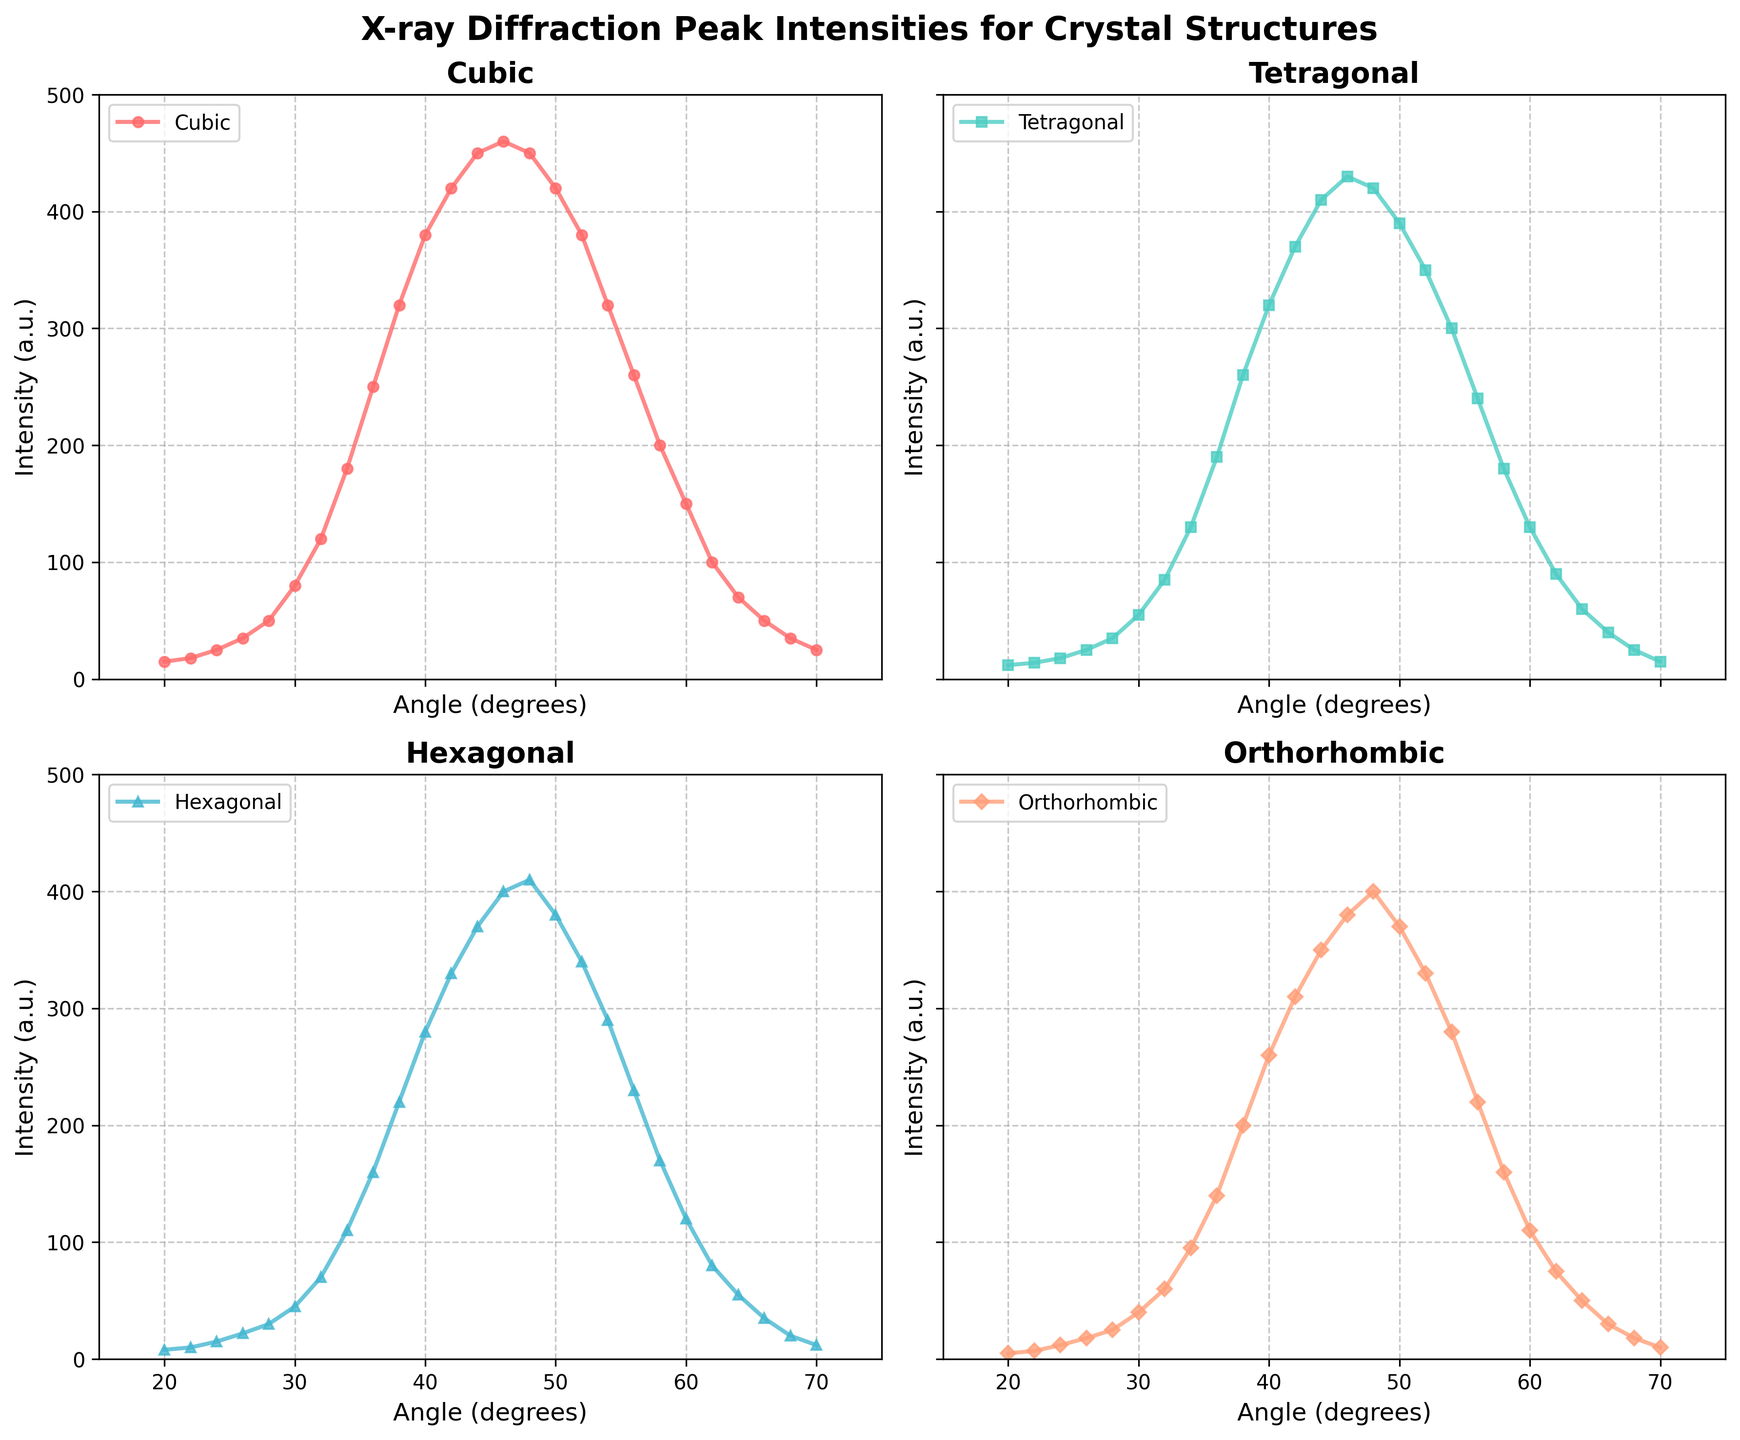Which structure shows the highest peak intensity at any angle? The plot with the highest peak intensity is the subplot corresponding to the Cubic structure. The peak intensity for the Cubic structure occurs around 46 degrees, with an intensity of about 460 a.u.
Answer: Cubic Which angle corresponds to the maximum intensity of the Tetragonal structure? The maximum intensity for the Tetragonal structure is found at the angle where the intensity is the highest in the subplot for Tetragonal. This occurs around 48 degrees, with an intensity of around 430 a.u.
Answer: 48 degrees For the Orthorhombic structure, what is the difference in intensity between the peaks at 34 degrees and 64 degrees? The intensity at 34 degrees is about 95 a.u., and at 64 degrees, it is approximately 50 a.u. The difference is 95 - 50 = 45 a.u.
Answer: 45 a.u Between 50 degrees and 60 degrees, which structure's intensity decreases the fastest? To determine this, look at the slope of the intensity lines between 50 degrees and 60 degrees for each structure. The Tetragonal structure's intensity drops from about 390 a.u. to 130 a.u., which is the steepest decrease among the structures.
Answer: Tetragonal What is the average intensity of the Hexagonal structure between 20 and 50 degrees? The intensity values for Hexagonal between 20 and 50 degrees are 8, 10, 15, 22, 30, 45, 70, 110, 160, 220, 280, 330, 370, 400, 410, 380. Summing these values gives 3630. There are 16 data points, so the average is 3630 / 16 = 226.875 a.u.
Answer: 226.875 a.u How does the intensity of the Cubic structure at 40 degrees compare to the Tetragonal structure's intensity at 60 degrees? The intensity of the Cubic structure at 40 degrees is approximately 380 a.u., while the intensity of the Tetragonal structure at 60 degrees is about 130 a.u. Therefore, the Cubic structure's intensity at 40 degrees is significantly higher than the Tetragonal's at 60 degrees.
Answer: Cubic at 40 degrees is higher At which angle does the intensity of the Orthorhombic structure first exceed 300 a.u., and by how much? In the Orthorhombic subplot, the intensity first exceeds 300 a.u. at around 34 degrees with an intensity of approximately 310 a.u. This means it exceeds 300 a.u. by 310 - 300 = 10 a.u.
Answer: 34 degrees, by 10 a.u If we average the maximum peak intensities of all four structures, what is the result? The maximum intensities are 460 a.u. (Cubic), 430 a.u. (Tetragonal), 410 a.u. (Hexagonal), and 400 a.u. (Orthorhombic). Summing these gives 460 + 430 + 410 + 400 = 1700. There are 4 structures, so the average is 1700 / 4 = 425 a.u.
Answer: 425 a.u Is there any angle where the peak intensity is the same for any two structures? At an angle of approximately 48 degrees, the peak intensity for the Cubic and Orthorhombic structures is near 450 a.u. Verify by checking the subplots where the intensities cross.
Answer: Yes, at 48 degrees 